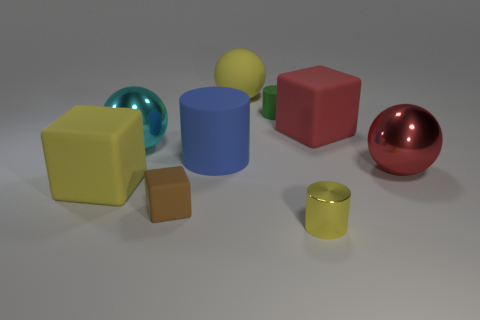How many other objects are the same size as the matte sphere?
Keep it short and to the point. 5. Does the cylinder that is to the right of the tiny green matte thing have the same material as the large blue cylinder?
Offer a terse response. No. What number of other things are the same color as the tiny metallic cylinder?
Provide a short and direct response. 2. How many other things are there of the same shape as the cyan object?
Give a very brief answer. 2. There is a large yellow matte object behind the cyan object; is its shape the same as the big metal thing right of the tiny brown rubber object?
Your answer should be compact. Yes. Is the number of large matte cubes that are to the right of the blue cylinder the same as the number of big blocks behind the big yellow rubber block?
Your response must be concise. Yes. There is a brown rubber object that is in front of the big metallic ball that is to the left of the large yellow rubber thing that is behind the big yellow block; what shape is it?
Offer a very short reply. Cube. Is the tiny cylinder that is in front of the red metal ball made of the same material as the big block right of the small yellow metallic cylinder?
Offer a very short reply. No. What is the shape of the big yellow matte object in front of the big red rubber cube?
Make the answer very short. Cube. Are there fewer small red rubber cylinders than cyan metallic things?
Your answer should be compact. Yes. 